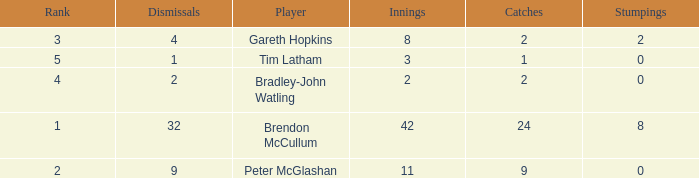List the ranks of all dismissals with a value of 4 3.0. 